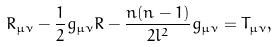<formula> <loc_0><loc_0><loc_500><loc_500>\ R _ { \mu \nu } - \frac { 1 } { 2 } g _ { \mu \nu } R - \frac { n ( n - 1 ) } { 2 l ^ { 2 } } g _ { \mu \nu } = T _ { \mu \nu } ,</formula> 